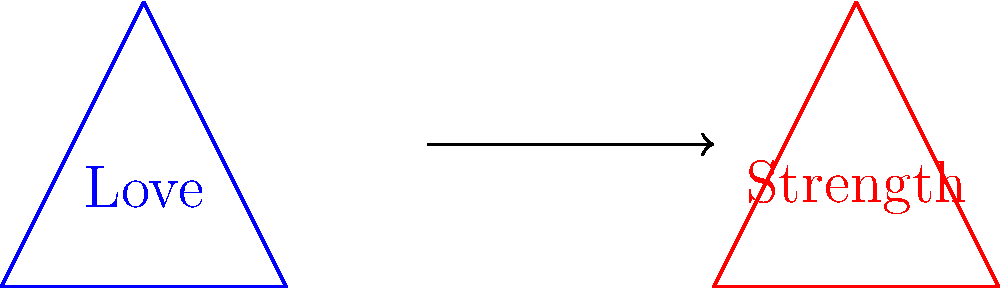In the diagram above, two triangles represent positive affirmations. The blue triangle represents "Love" and the red triangle represents "Strength". If the blue triangle is translated 3 units to the right and 1 unit up to become the red triangle, what transformation can be described mathematically to move the affirmation "Love" to the position of "Strength"? To solve this problem, we need to follow these steps:

1. Identify the translation vector:
   - The blue triangle moves 3 units right (x-direction) and 1 unit up (y-direction).
   - This can be represented as a vector $(3,1)$.

2. Express the translation mathematically:
   - In coordinate geometry, a translation by vector $(a,b)$ is represented as:
     $T_{(a,b)}(x,y) = (x+a, y+b)$

3. Apply the translation to this specific case:
   - Here, $a=3$ and $b=1$
   - So, the transformation can be written as:
     $T_{(3,1)}(x,y) = (x+3, y+1)$

This transformation will move any point of the blue triangle to its corresponding point on the red triangle, effectively translating the affirmation "Love" to the position of "Strength".
Answer: $T_{(3,1)}(x,y) = (x+3, y+1)$ 